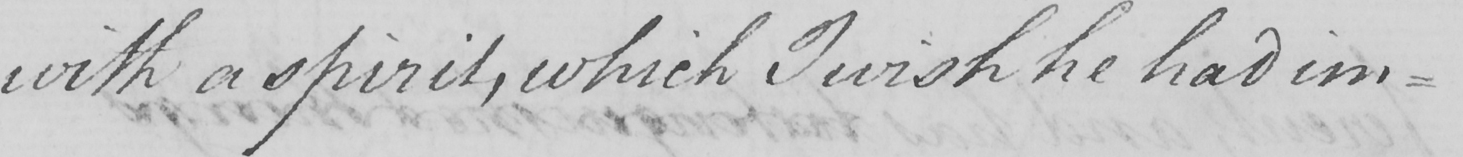What is written in this line of handwriting? with a spirit , which I wish he had im- 